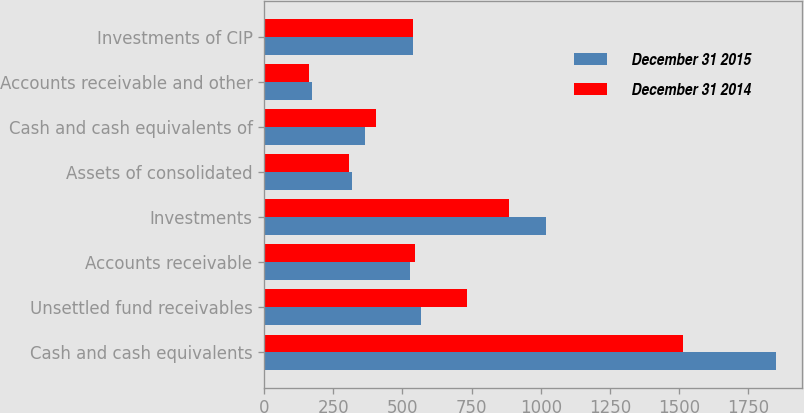<chart> <loc_0><loc_0><loc_500><loc_500><stacked_bar_chart><ecel><fcel>Cash and cash equivalents<fcel>Unsettled fund receivables<fcel>Accounts receivable<fcel>Investments<fcel>Assets of consolidated<fcel>Cash and cash equivalents of<fcel>Accounts receivable and other<fcel>Investments of CIP<nl><fcel>December 31 2015<fcel>1851.4<fcel>566.3<fcel>528.1<fcel>1019.1<fcel>319.1<fcel>363.3<fcel>173.5<fcel>537<nl><fcel>December 31 2014<fcel>1514.2<fcel>732.4<fcel>545.9<fcel>885.4<fcel>305.8<fcel>404<fcel>161.3<fcel>537<nl></chart> 